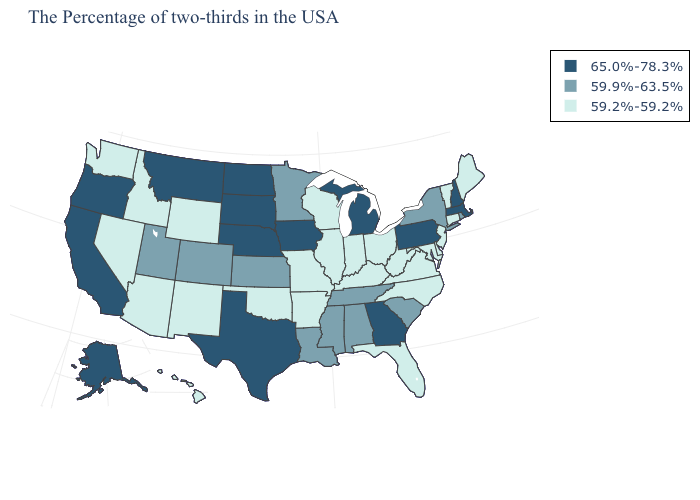Does Hawaii have a higher value than Vermont?
Give a very brief answer. No. What is the value of Mississippi?
Quick response, please. 59.9%-63.5%. What is the value of South Carolina?
Keep it brief. 59.9%-63.5%. What is the value of Tennessee?
Be succinct. 59.9%-63.5%. Among the states that border Georgia , does South Carolina have the lowest value?
Quick response, please. No. Which states have the highest value in the USA?
Short answer required. Massachusetts, New Hampshire, Pennsylvania, Georgia, Michigan, Iowa, Nebraska, Texas, South Dakota, North Dakota, Montana, California, Oregon, Alaska. What is the highest value in the MidWest ?
Quick response, please. 65.0%-78.3%. What is the lowest value in states that border Kansas?
Answer briefly. 59.2%-59.2%. What is the value of Ohio?
Short answer required. 59.2%-59.2%. Among the states that border Illinois , which have the lowest value?
Keep it brief. Kentucky, Indiana, Wisconsin, Missouri. What is the highest value in states that border Michigan?
Short answer required. 59.2%-59.2%. Name the states that have a value in the range 65.0%-78.3%?
Quick response, please. Massachusetts, New Hampshire, Pennsylvania, Georgia, Michigan, Iowa, Nebraska, Texas, South Dakota, North Dakota, Montana, California, Oregon, Alaska. What is the highest value in the South ?
Be succinct. 65.0%-78.3%. What is the lowest value in the USA?
Concise answer only. 59.2%-59.2%. What is the value of South Dakota?
Be succinct. 65.0%-78.3%. 